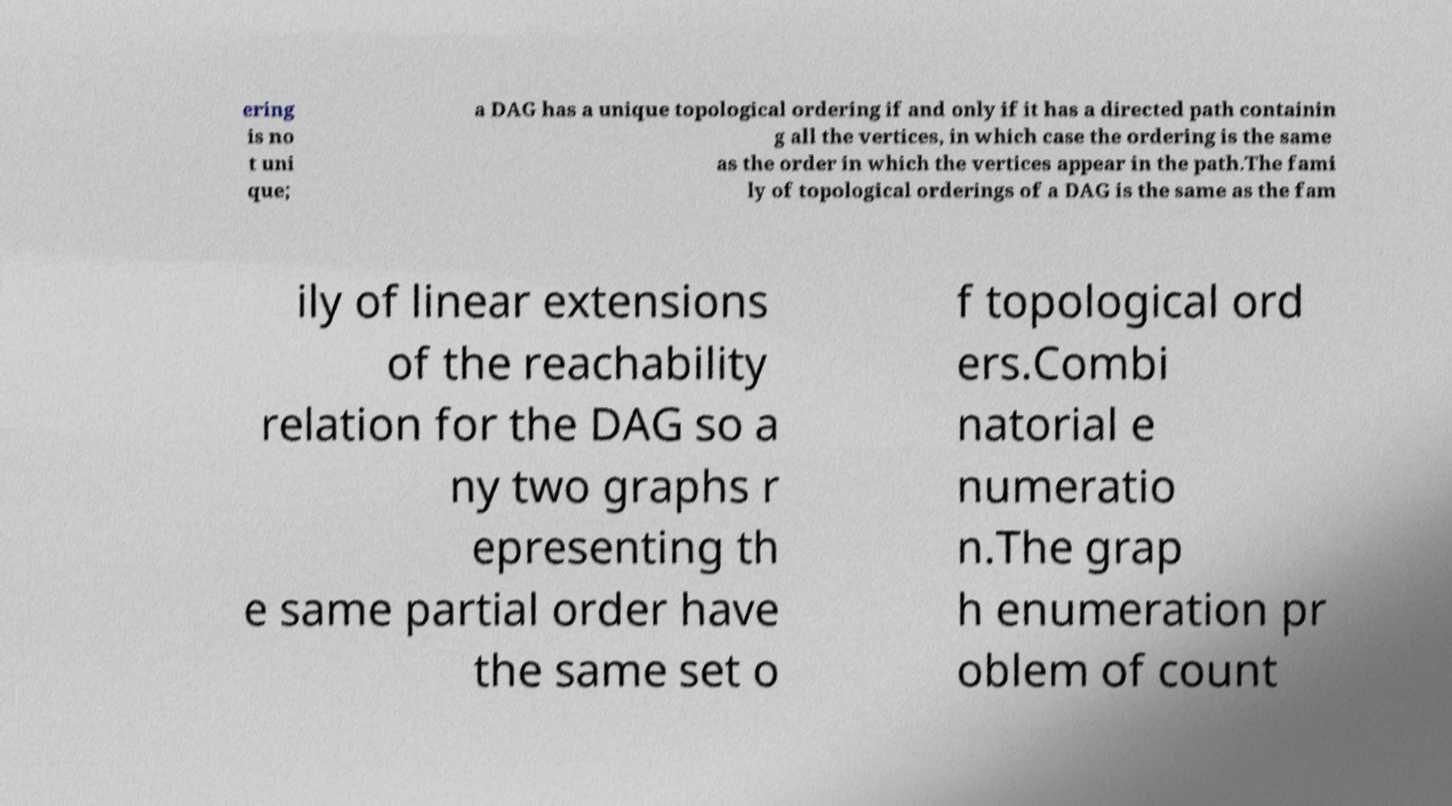For documentation purposes, I need the text within this image transcribed. Could you provide that? ering is no t uni que; a DAG has a unique topological ordering if and only if it has a directed path containin g all the vertices, in which case the ordering is the same as the order in which the vertices appear in the path.The fami ly of topological orderings of a DAG is the same as the fam ily of linear extensions of the reachability relation for the DAG so a ny two graphs r epresenting th e same partial order have the same set o f topological ord ers.Combi natorial e numeratio n.The grap h enumeration pr oblem of count 